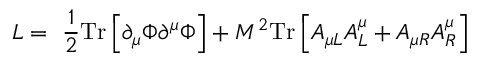Convert formula to latex. <formula><loc_0><loc_0><loc_500><loc_500>L = \frac { 1 } { 2 } T r \left [ \partial _ { \mu } \Phi \partial ^ { \mu } \Phi \right ] + M ^ { 2 } T r \left [ A _ { \mu L } A _ { L } ^ { \mu } + A _ { \mu R } A _ { R } ^ { \mu } \right ] \,</formula> 